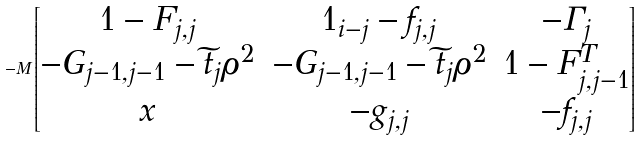<formula> <loc_0><loc_0><loc_500><loc_500>- M \begin{bmatrix} 1 - F _ { j , j } & 1 _ { i - j } - f _ { j , j } & - \Gamma _ { j } \\ - G _ { j - 1 , j - 1 } - \widetilde { t } _ { j } \rho ^ { 2 } & - G _ { j - 1 , j - 1 } - \widetilde { t } _ { j } \rho ^ { 2 } & 1 - F _ { j , j - 1 } ^ { T } \\ x & - g _ { j , j } & - f _ { j , j } \end{bmatrix}</formula> 